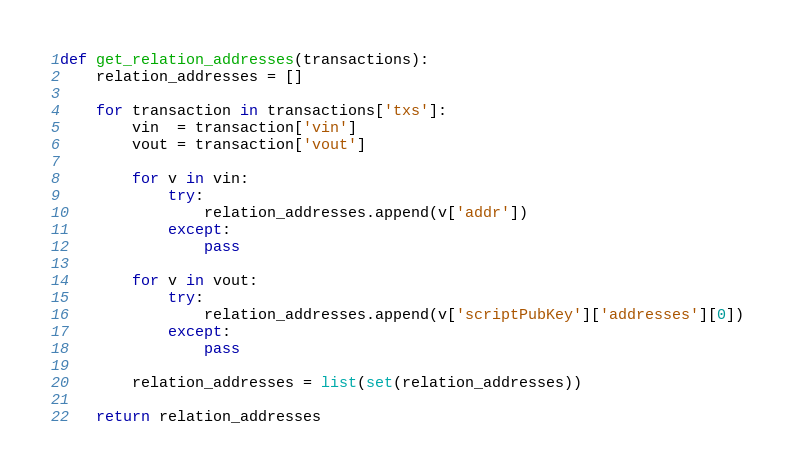Convert code to text. <code><loc_0><loc_0><loc_500><loc_500><_Python_>def get_relation_addresses(transactions):
	relation_addresses = []

	for transaction in transactions['txs']:
		vin  = transaction['vin']
		vout = transaction['vout']

		for v in vin:
			try:
				relation_addresses.append(v['addr'])
			except:
				pass

		for v in vout:
			try:
				relation_addresses.append(v['scriptPubKey']['addresses'][0])
			except:
				pass

		relation_addresses = list(set(relation_addresses))

	return relation_addresses</code> 